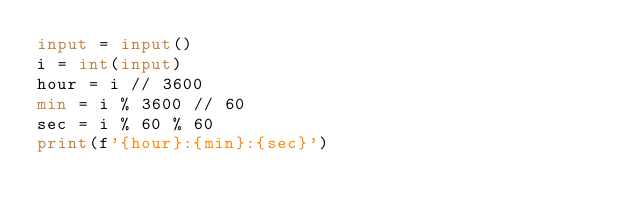<code> <loc_0><loc_0><loc_500><loc_500><_Python_>input = input()
i = int(input)
hour = i // 3600
min = i % 3600 // 60
sec = i % 60 % 60
print(f'{hour}:{min}:{sec}')
</code> 